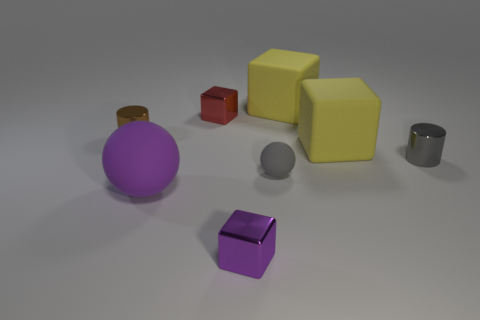How many yellow cubes must be subtracted to get 1 yellow cubes? 1 Subtract 1 blocks. How many blocks are left? 3 Add 2 purple metallic things. How many objects exist? 10 Subtract all spheres. How many objects are left? 6 Add 4 big gray metallic cylinders. How many big gray metallic cylinders exist? 4 Subtract 1 purple spheres. How many objects are left? 7 Subtract all large yellow matte objects. Subtract all big yellow cubes. How many objects are left? 4 Add 7 tiny red shiny cubes. How many tiny red shiny cubes are left? 8 